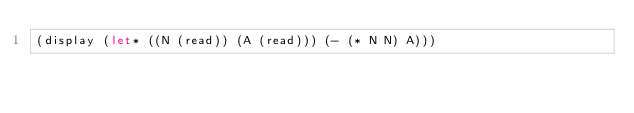Convert code to text. <code><loc_0><loc_0><loc_500><loc_500><_Scheme_>(display (let* ((N (read)) (A (read))) (- (* N N) A)))</code> 